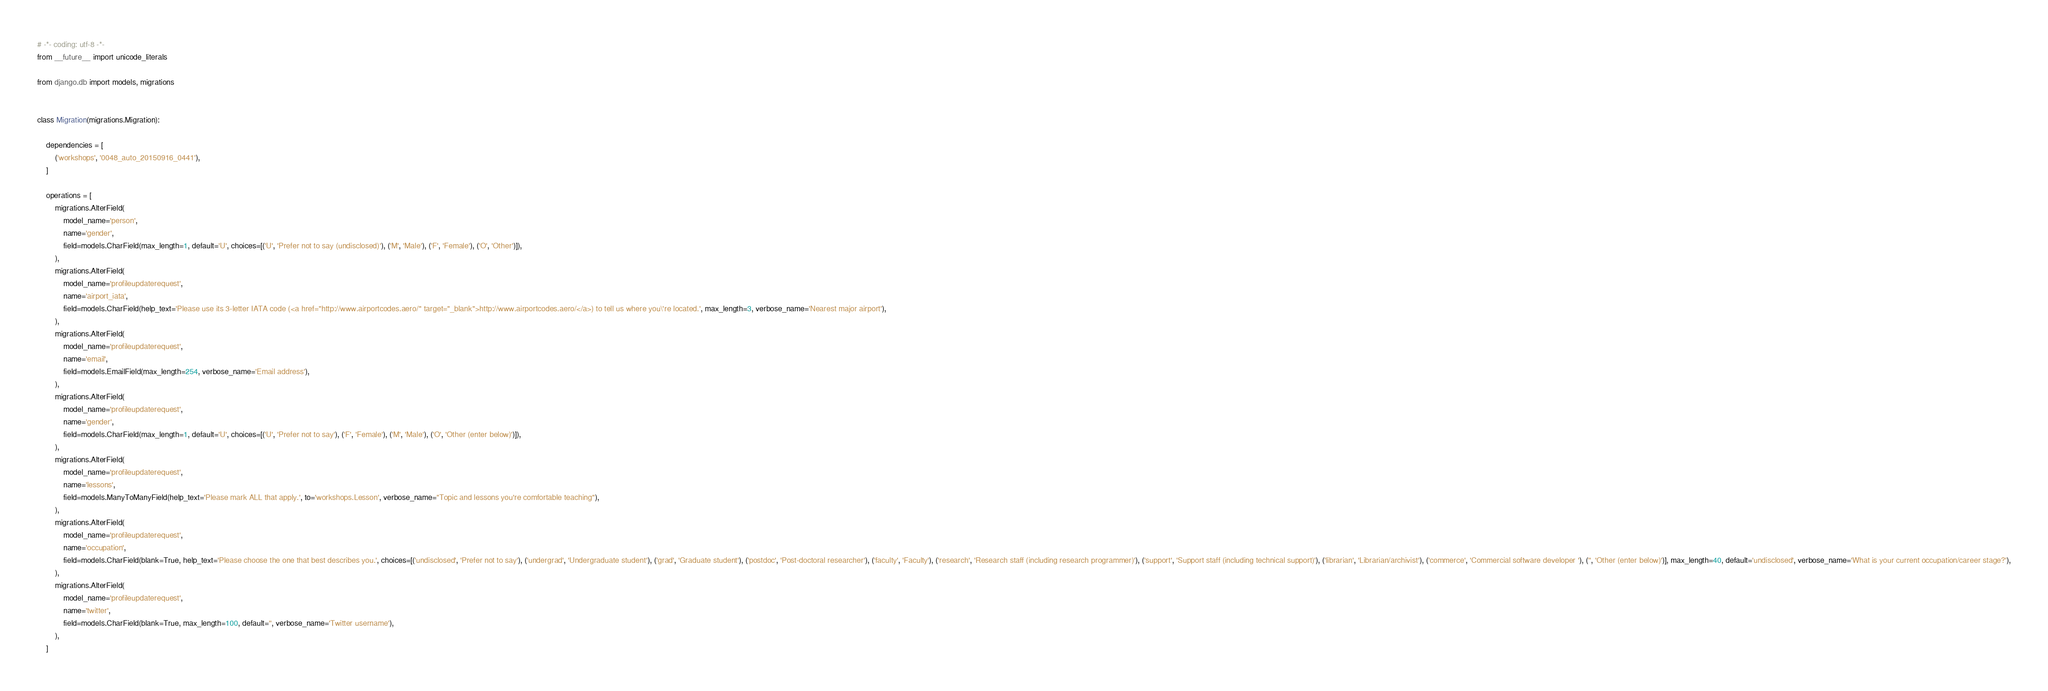<code> <loc_0><loc_0><loc_500><loc_500><_Python_># -*- coding: utf-8 -*-
from __future__ import unicode_literals

from django.db import models, migrations


class Migration(migrations.Migration):

    dependencies = [
        ('workshops', '0048_auto_20150916_0441'),
    ]

    operations = [
        migrations.AlterField(
            model_name='person',
            name='gender',
            field=models.CharField(max_length=1, default='U', choices=[('U', 'Prefer not to say (undisclosed)'), ('M', 'Male'), ('F', 'Female'), ('O', 'Other')]),
        ),
        migrations.AlterField(
            model_name='profileupdaterequest',
            name='airport_iata',
            field=models.CharField(help_text='Please use its 3-letter IATA code (<a href="http://www.airportcodes.aero/" target="_blank">http://www.airportcodes.aero/</a>) to tell us where you\'re located.', max_length=3, verbose_name='Nearest major airport'),
        ),
        migrations.AlterField(
            model_name='profileupdaterequest',
            name='email',
            field=models.EmailField(max_length=254, verbose_name='Email address'),
        ),
        migrations.AlterField(
            model_name='profileupdaterequest',
            name='gender',
            field=models.CharField(max_length=1, default='U', choices=[('U', 'Prefer not to say'), ('F', 'Female'), ('M', 'Male'), ('O', 'Other (enter below)')]),
        ),
        migrations.AlterField(
            model_name='profileupdaterequest',
            name='lessons',
            field=models.ManyToManyField(help_text='Please mark ALL that apply.', to='workshops.Lesson', verbose_name="Topic and lessons you're comfortable teaching"),
        ),
        migrations.AlterField(
            model_name='profileupdaterequest',
            name='occupation',
            field=models.CharField(blank=True, help_text='Please choose the one that best describes you.', choices=[('undisclosed', 'Prefer not to say'), ('undergrad', 'Undergraduate student'), ('grad', 'Graduate student'), ('postdoc', 'Post-doctoral researcher'), ('faculty', 'Faculty'), ('research', 'Research staff (including research programmer)'), ('support', 'Support staff (including technical support)'), ('librarian', 'Librarian/archivist'), ('commerce', 'Commercial software developer '), ('', 'Other (enter below)')], max_length=40, default='undisclosed', verbose_name='What is your current occupation/career stage?'),
        ),
        migrations.AlterField(
            model_name='profileupdaterequest',
            name='twitter',
            field=models.CharField(blank=True, max_length=100, default='', verbose_name='Twitter username'),
        ),
    ]
</code> 